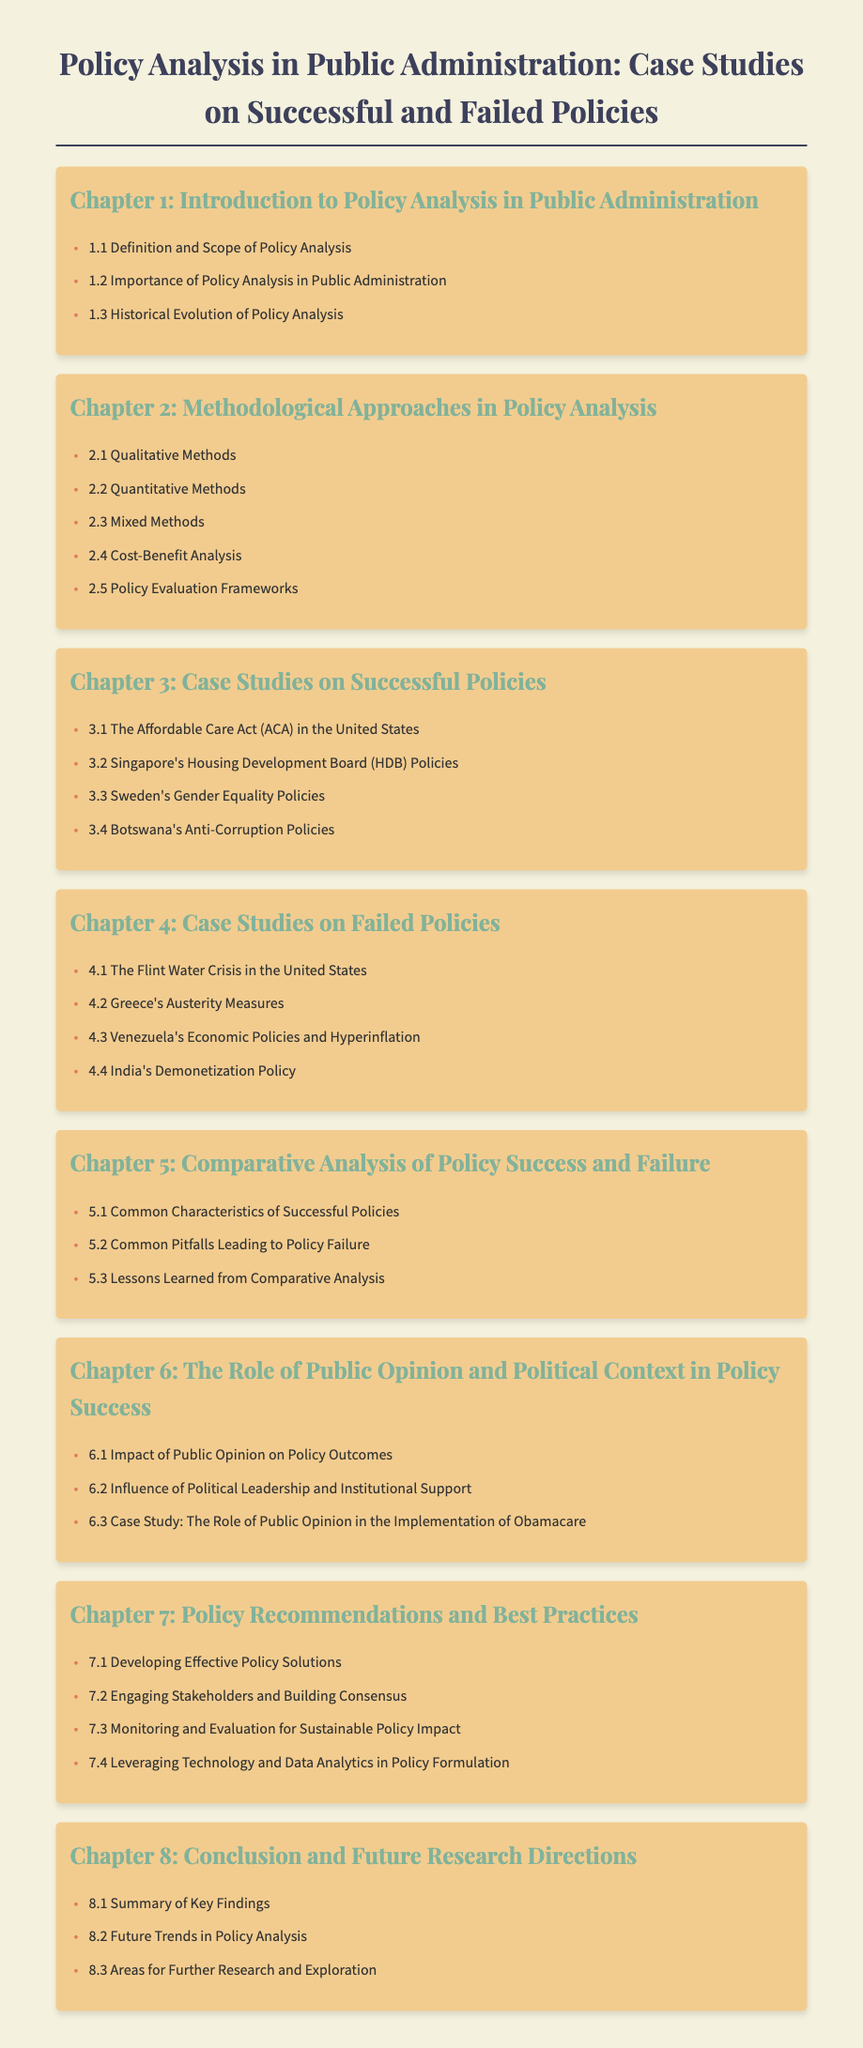What is the title of the document? The title is the main heading of the document, which summarizes its focus.
Answer: Policy Analysis in Public Administration: Case Studies on Successful and Failed Policies How many chapters are there in the document? The document lists multiple chapters, indicating the structure of the content.
Answer: 8 What is addressed in Chapter 3? Chapter 3 discusses a specific type of case studies, which are typically focused on successes in policy implementation.
Answer: Case Studies on Successful Policies Name one case study on failed policy listed in Chapter 4. The answer is a specific example of failed policy provided in the chapter.
Answer: Flint Water Crisis What is one of the methodological approaches mentioned in Chapter 2? The document outlines various approaches used in policy analysis, making it a key subject in that chapter.
Answer: Qualitative Methods Which chapter discusses the role of public opinion in policy success? This chapter focuses on external factors affecting policy success, emphasizing the importance of societal elements.
Answer: Chapter 6 What type of analysis is covered in Chapter 5? This chapter focuses on comparing successful and failed policies, which is a analytical strategy.
Answer: Comparative Analysis of Policy Success and Failure What does Chapter 8 summarize? Chapter 8 wraps up the findings and discusses future directions, which is typical for concluding sections.
Answer: Summary of Key Findings 